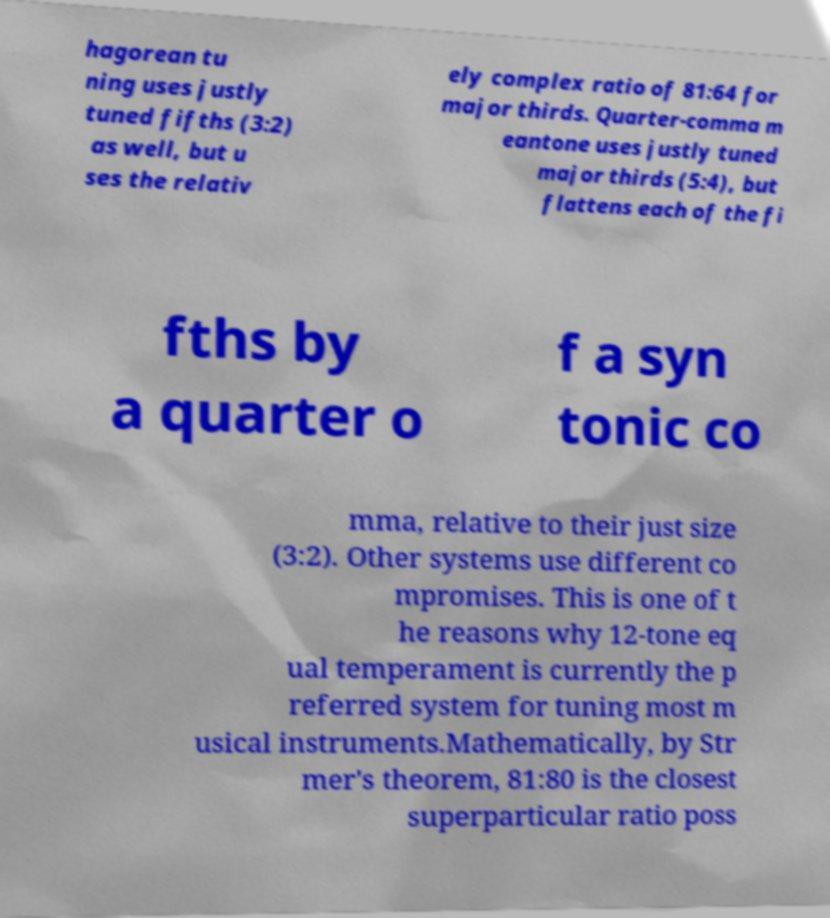What messages or text are displayed in this image? I need them in a readable, typed format. hagorean tu ning uses justly tuned fifths (3:2) as well, but u ses the relativ ely complex ratio of 81:64 for major thirds. Quarter-comma m eantone uses justly tuned major thirds (5:4), but flattens each of the fi fths by a quarter o f a syn tonic co mma, relative to their just size (3:2). Other systems use different co mpromises. This is one of t he reasons why 12-tone eq ual temperament is currently the p referred system for tuning most m usical instruments.Mathematically, by Str mer's theorem, 81:80 is the closest superparticular ratio poss 